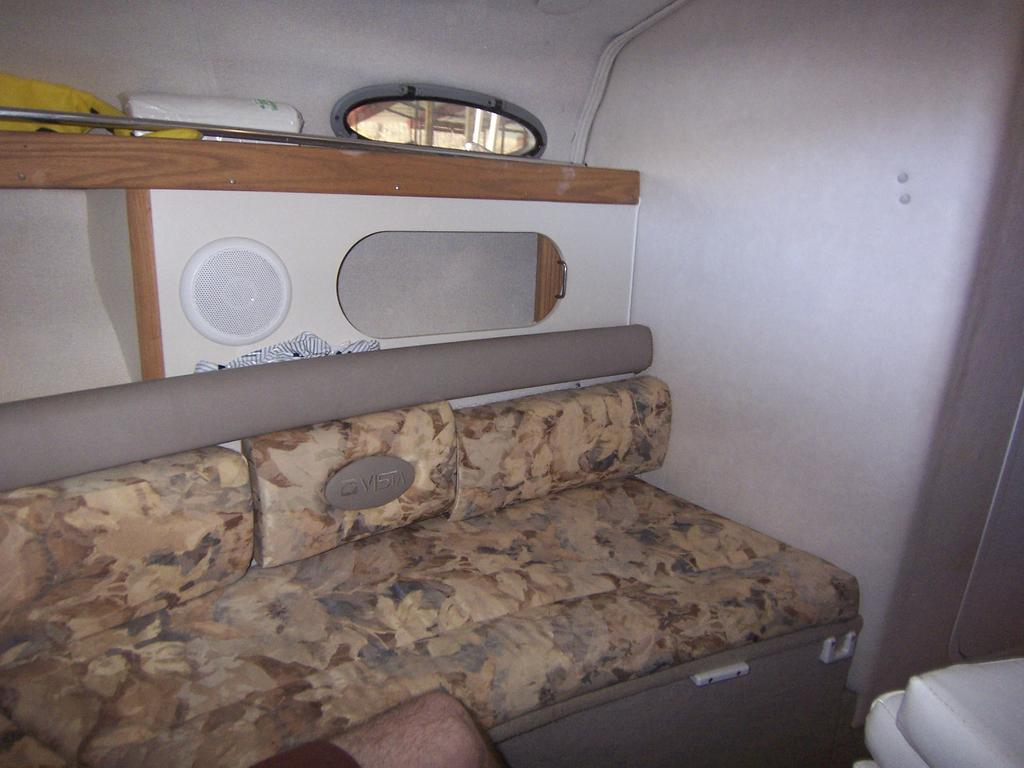What type of furniture is in the image? There is a sofa in the image. Can you describe any part of a person in the image? A person's leg is visible in the image. What is located on the right side of the image? There is an object on the right side of the image. What can be seen in the background of the image? There is a window, objects on a platform, and cloth in the background of the image. Are there any other objects visible in the background of the image? Yes, there are other objects visible in the background of the image. What type of breakfast is being prepared by the actor in the image? There is no actor or breakfast preparation present in the image. How many mice can be seen running around on the sofa in the image? There are no mice visible in the image. 